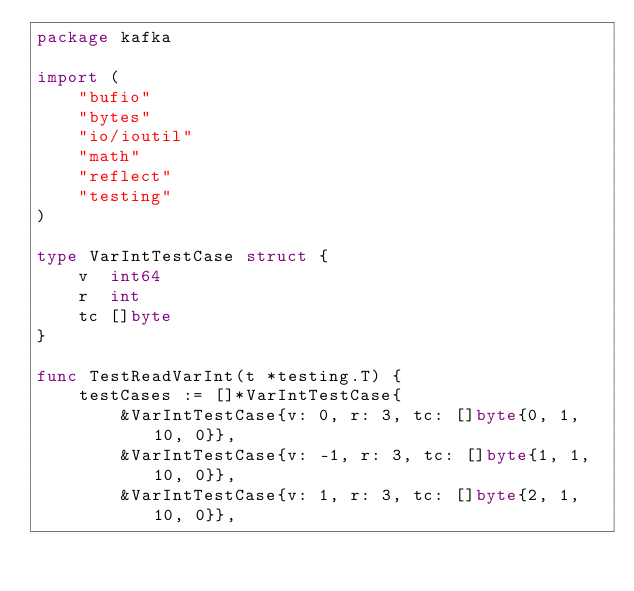Convert code to text. <code><loc_0><loc_0><loc_500><loc_500><_Go_>package kafka

import (
	"bufio"
	"bytes"
	"io/ioutil"
	"math"
	"reflect"
	"testing"
)

type VarIntTestCase struct {
	v  int64
	r  int
	tc []byte
}

func TestReadVarInt(t *testing.T) {
	testCases := []*VarIntTestCase{
		&VarIntTestCase{v: 0, r: 3, tc: []byte{0, 1, 10, 0}},
		&VarIntTestCase{v: -1, r: 3, tc: []byte{1, 1, 10, 0}},
		&VarIntTestCase{v: 1, r: 3, tc: []byte{2, 1, 10, 0}},</code> 